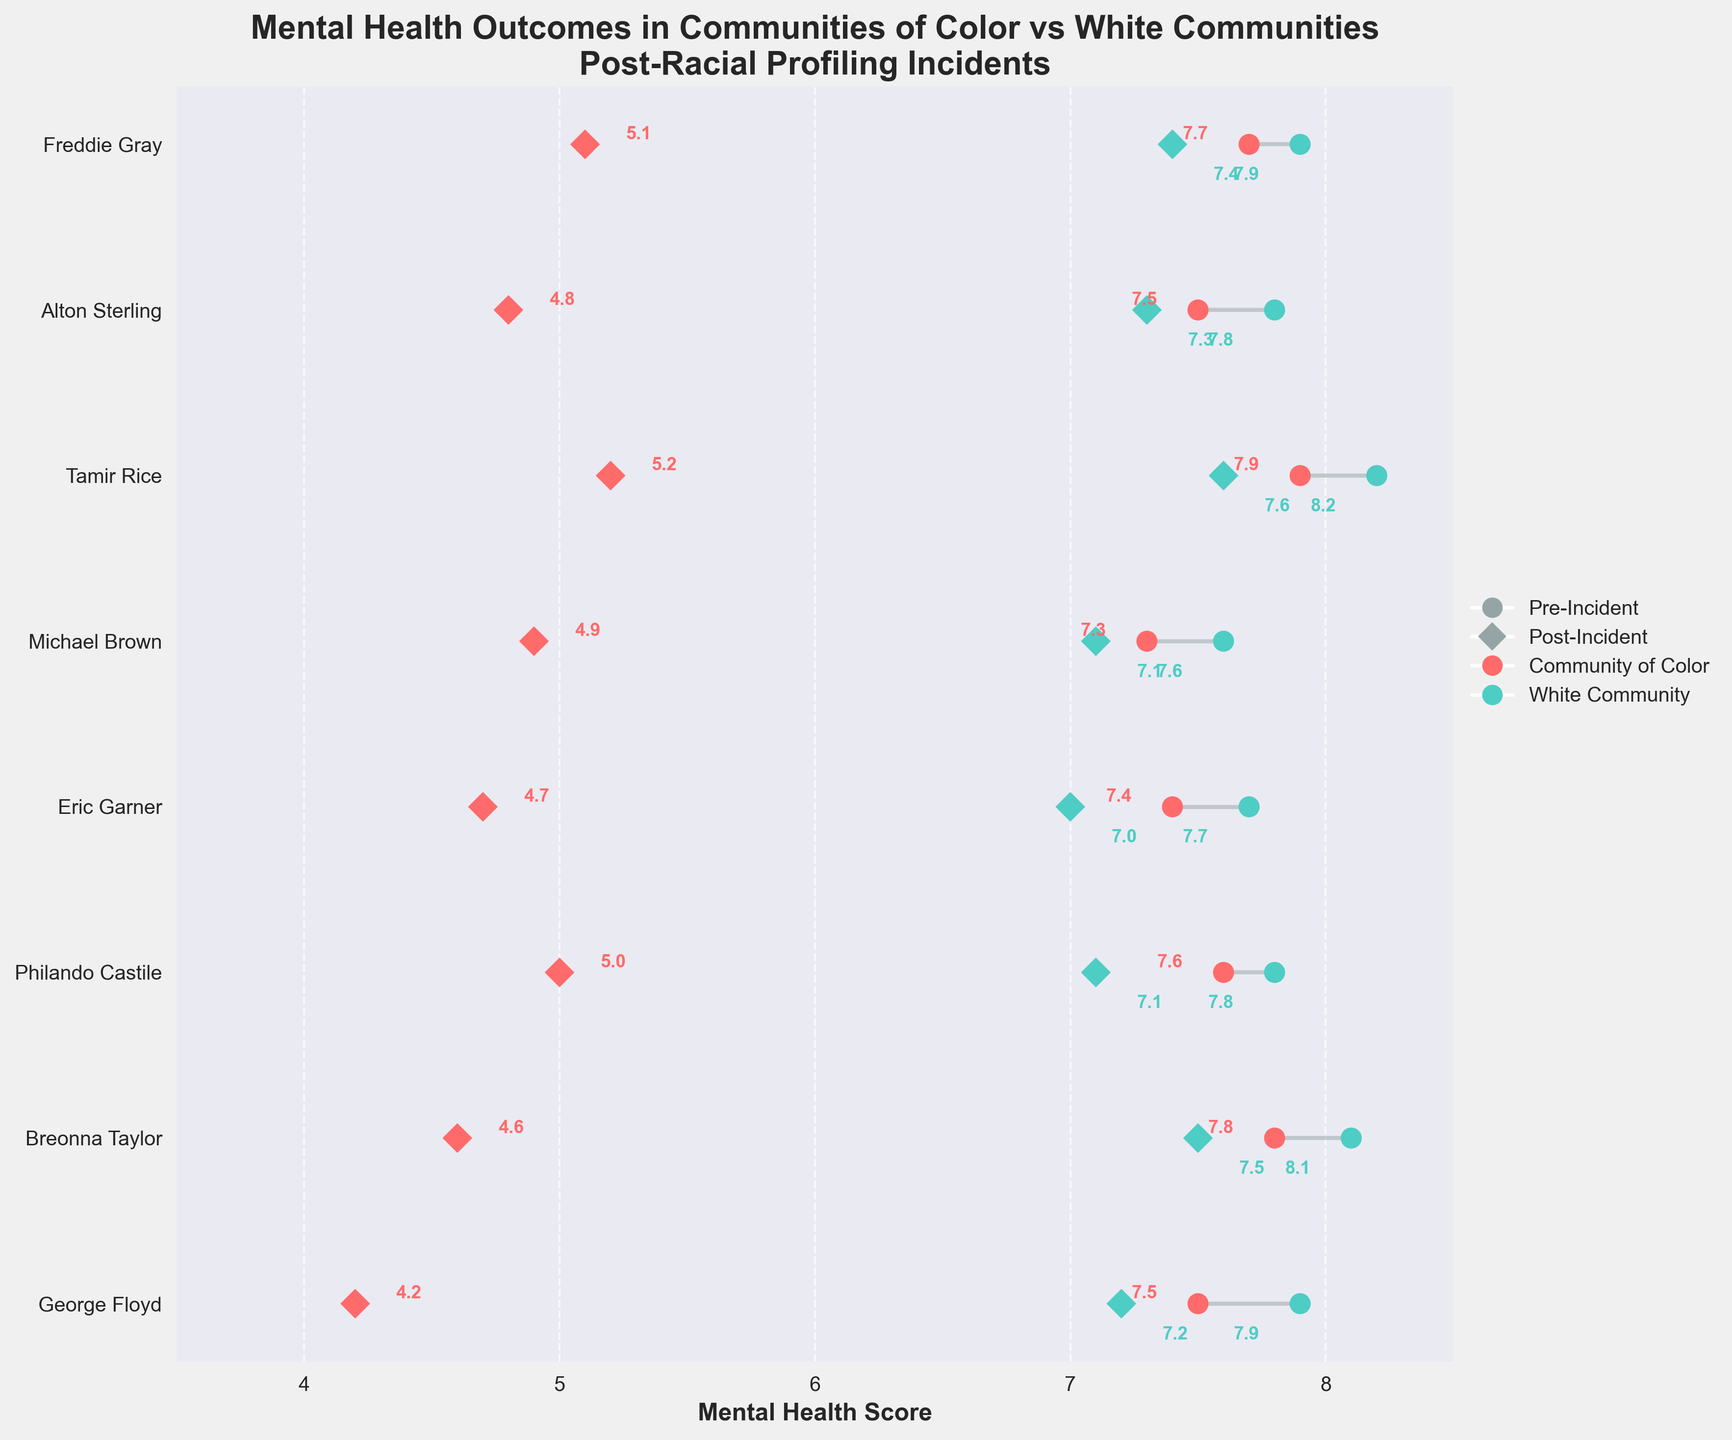What is the title of the plot? The title can be found at the top of the plot, which states "Mental Health Outcomes in Communities of Color vs White Communities Post-Racial Profiling Incidents".
Answer: Mental Health Outcomes in Communities of Color vs White Communities Post-Racial Profiling Incidents What are the two main community types represented in the plot? The legend at the right-hand side of the plot identifies the two community types, which are "Community of Color" and "White Community".
Answer: Community of Color and White Community Which incident showed the largest decrease in mental health score for the Community of Color? By comparing the difference between the pre-incident and post-incident mental health scores for each incident, the largest decrease for the Community of Color is found in the George Floyd incident, with scores dropping from 7.5 to 4.2.
Answer: George Floyd Whose mental health scores dropped more after the Philando Castile incident, the Community of Color or the White Community? We need to identify the pre-incident and post-incident scores for each community. For the Community of Color, the scores changed from 7.6 to 5.0 (a decrease of 2.6). For the White Community, the scores changed from 7.8 to 7.1 (a decrease of 0.7). Therefore, the Community of Color experienced a larger drop.
Answer: Community of Color On average, how much did the mental health scores decrease in the White Community post-incident? To find the average decrease, calculate the differences between pre-incident and post-incident scores for each incident in the White Community, sum them up, and divide by the number of incidents. The differences are (7.9-7.2), (8.1-7.5), (7.8-7.1), (7.7-7.0), (7.6-7.1), (8.2-7.6), (7.8-7.3), (7.9-7.4), resulting in an overall decrease of 4.8. Dividing by 8 incidents, the average decrease is 4.8/8 = 0.6.
Answer: 0.6 Which community (color-coded) showed more resilience in maintaining mental health post-incident? Resilience can be interpreted as having smaller drops in mental health scores. By comparing the overall drops indicated by the scatter plot markers, the White Community, color-coded in a teal shade, showed more resilience by having smaller decreases in scores compared to the Community of Color, color-coded in red.
Answer: White Community What is the mental health score difference post-incident between communities for the Tamir Rice incident? Retrieve the post-incident mental health scores for the Tamir Rice incident: Community of Color (5.2) and White Community (7.6). The difference is 7.6 - 5.2.
Answer: 2.4 Which incident had the highest pre-incident mental health score for the White Community? By checking the pre-incident scores on the plot for each incident for the White Community, the highest pre-incident score of 8.2 is seen for the Tamir Rice incident.
Answer: Tamir Rice How many unique incidents are represented in the plot? Count the unique incidents listed on the y-axis of the plot. There are 8 unique incidents.
Answer: 8 Does the plot show that mental health scores generally decrease more in Communities of Color or White Communities after racial profiling incidents? By evaluating the changes in scores indicated by the dumbbell plots, it is evident that most of the larger decreases occur among the Community of Color, with more significant drops compared to the White Community.
Answer: Communities of Color 